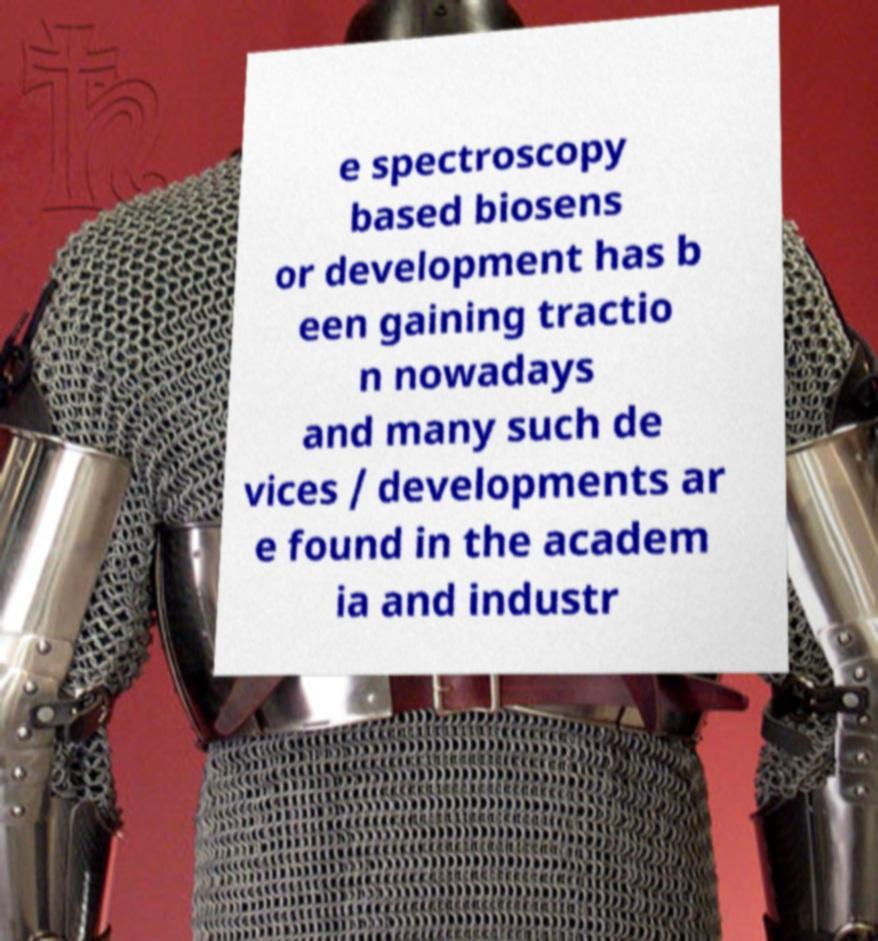For documentation purposes, I need the text within this image transcribed. Could you provide that? e spectroscopy based biosens or development has b een gaining tractio n nowadays and many such de vices / developments ar e found in the academ ia and industr 